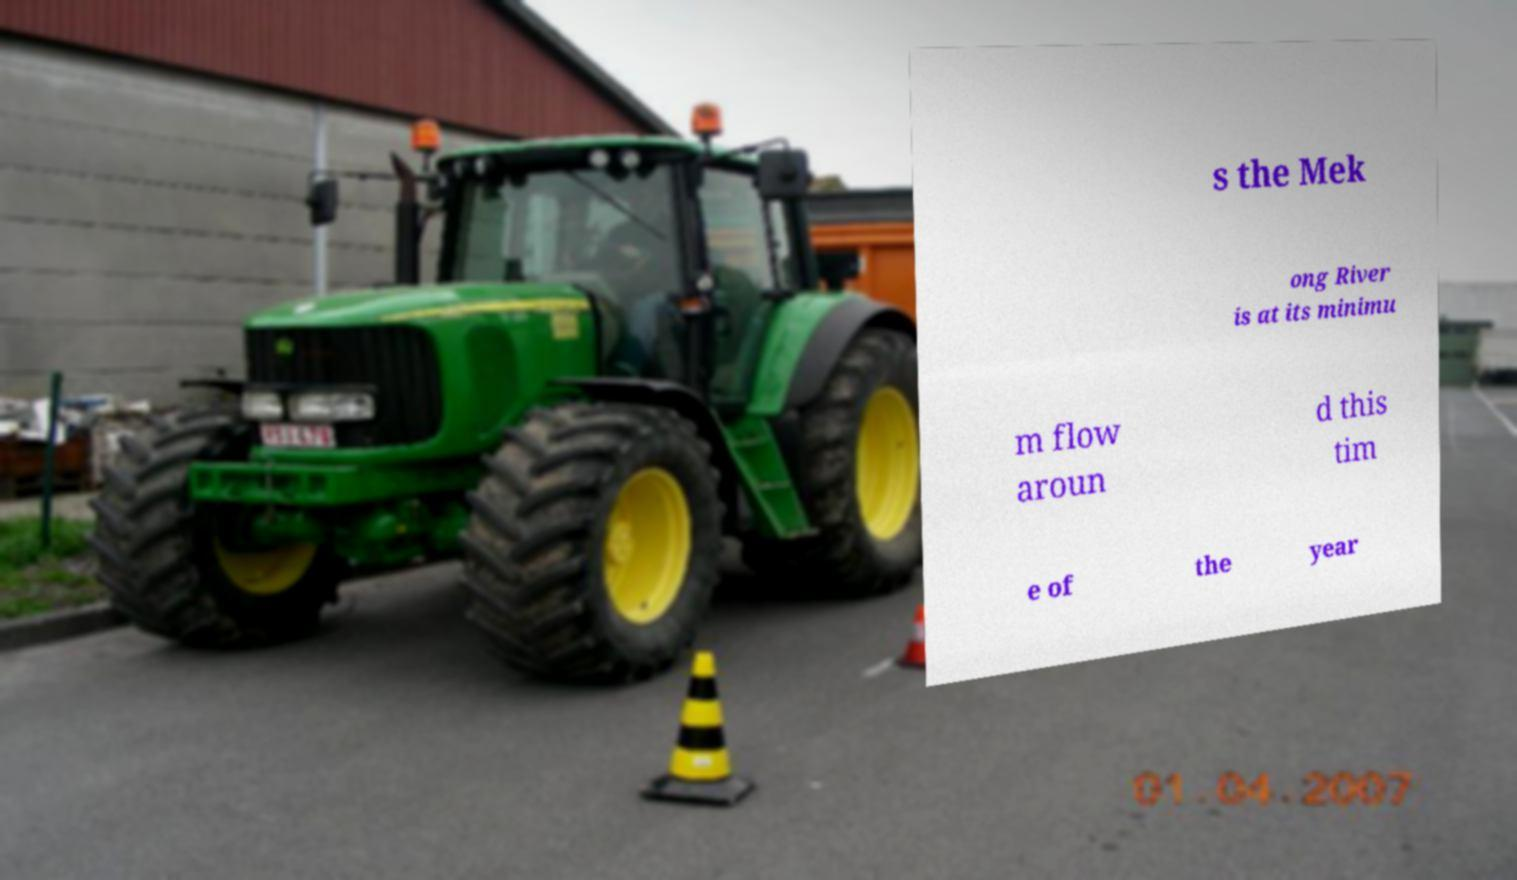Please identify and transcribe the text found in this image. s the Mek ong River is at its minimu m flow aroun d this tim e of the year 